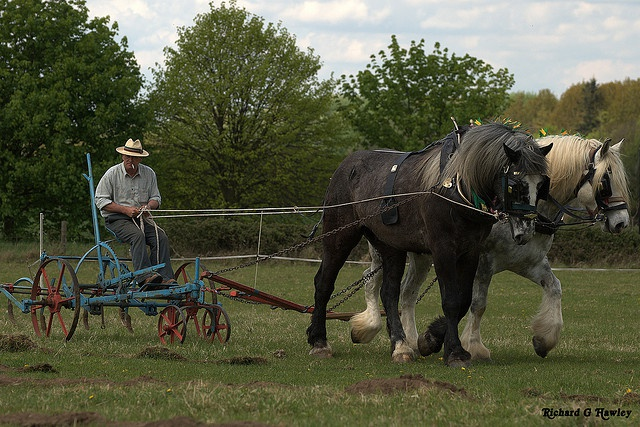Describe the objects in this image and their specific colors. I can see horse in gray and black tones, horse in gray, black, and darkgreen tones, and people in gray, black, darkgray, and maroon tones in this image. 